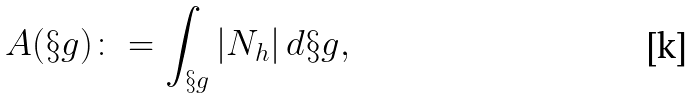Convert formula to latex. <formula><loc_0><loc_0><loc_500><loc_500>A ( \S g ) \colon = \int _ { \S g } | N _ { h } | \, d \S g ,</formula> 